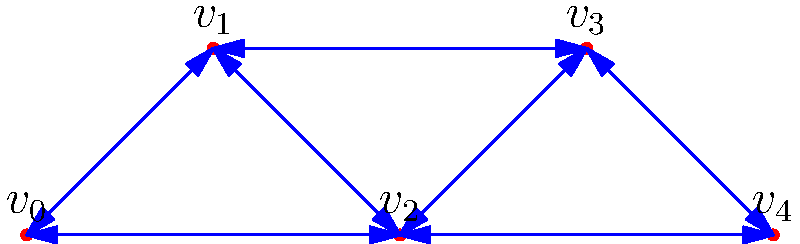In a covert operation, you need to establish secure communication channels between five strategic locations ($v_0$ to $v_4$). The graph represents the possible connections, with edge weights indicating the risk level of each connection. Using Kruskal's algorithm for finding the minimum spanning tree, what is the total risk level of the optimal secure network? To solve this problem using Kruskal's algorithm for finding the minimum spanning tree:

1. Sort all edges by weight (risk level) in ascending order:
   (0,2): 5
   (2,4): 6
   (3,4): 7
   (0,1): 8
   (1,2): 9
   (1,3): 11
   (2,3): 15

2. Start with an empty set of edges and add edges in order if they don't create a cycle:

   a. Add (0,2): 5
   b. Add (2,4): 6
   c. Add (3,4): 7
   d. Add (0,1): 8

3. Stop here as we have added 4 edges, which is enough to connect all 5 vertices.

4. The minimum spanning tree consists of edges:
   (0,2), (2,4), (3,4), (0,1)

5. Calculate the total risk level:
   $5 + 6 + 7 + 8 = 26$

Therefore, the total risk level of the optimal secure network is 26.
Answer: 26 